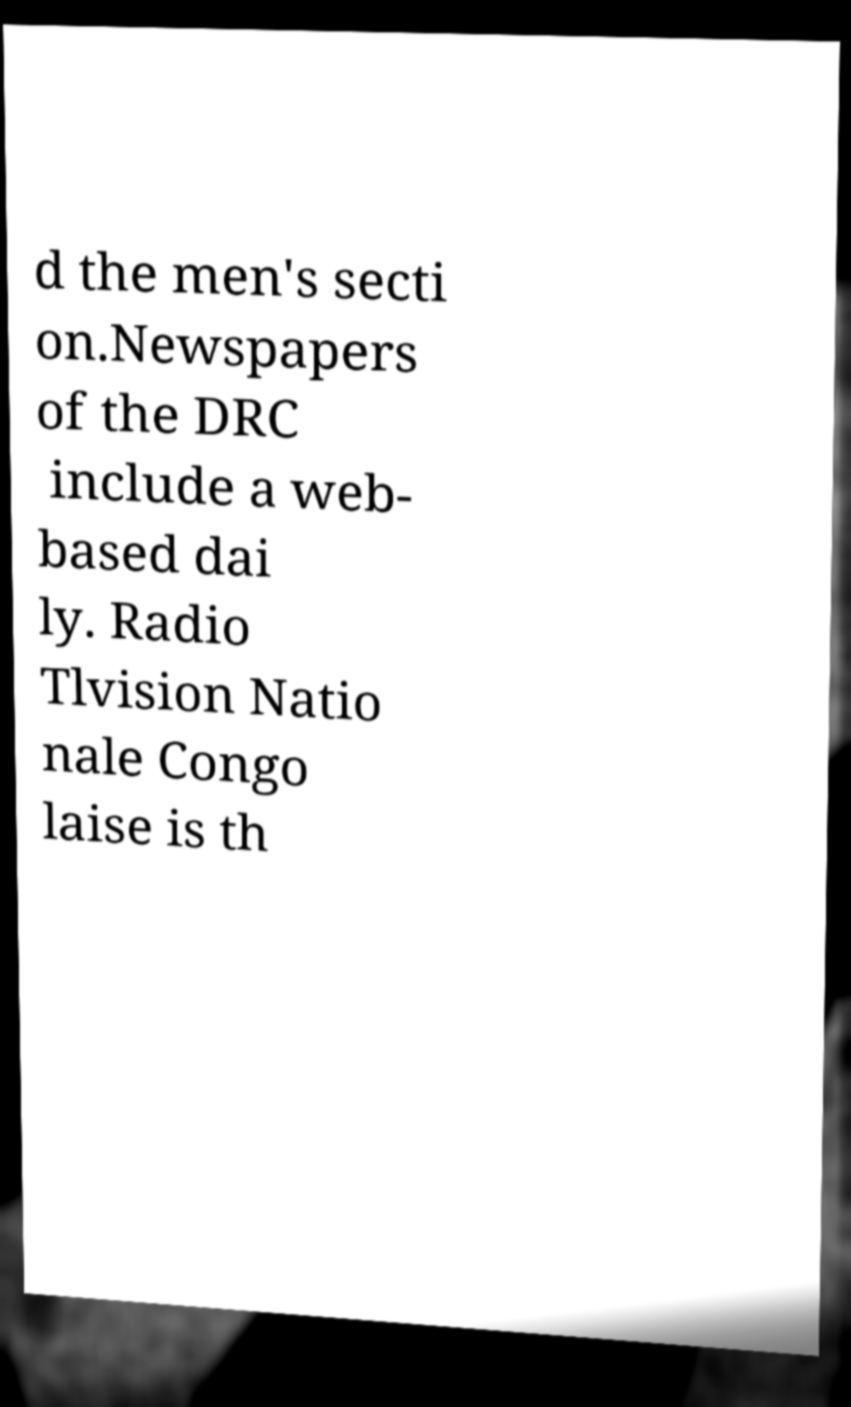Please read and relay the text visible in this image. What does it say? d the men's secti on.Newspapers of the DRC include a web- based dai ly. Radio Tlvision Natio nale Congo laise is th 